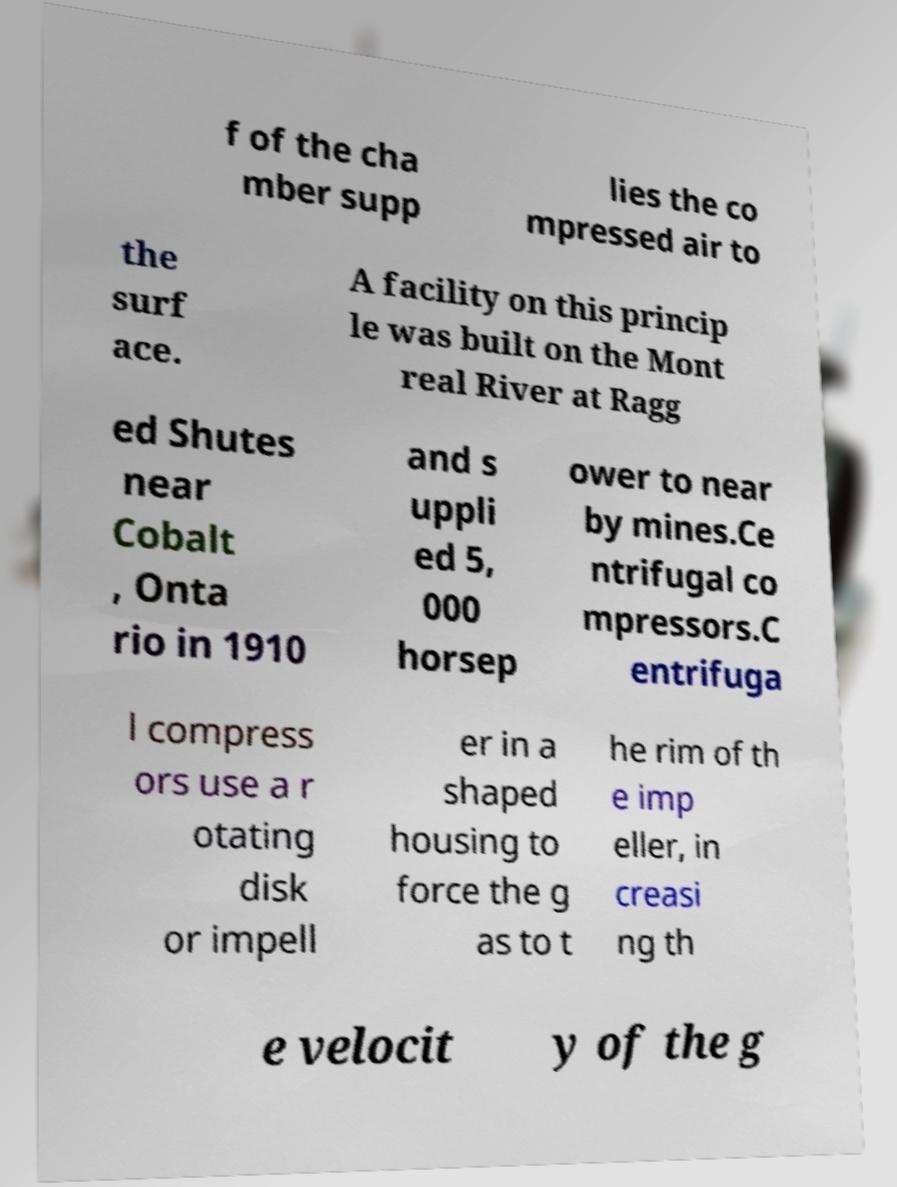Could you extract and type out the text from this image? f of the cha mber supp lies the co mpressed air to the surf ace. A facility on this princip le was built on the Mont real River at Ragg ed Shutes near Cobalt , Onta rio in 1910 and s uppli ed 5, 000 horsep ower to near by mines.Ce ntrifugal co mpressors.C entrifuga l compress ors use a r otating disk or impell er in a shaped housing to force the g as to t he rim of th e imp eller, in creasi ng th e velocit y of the g 